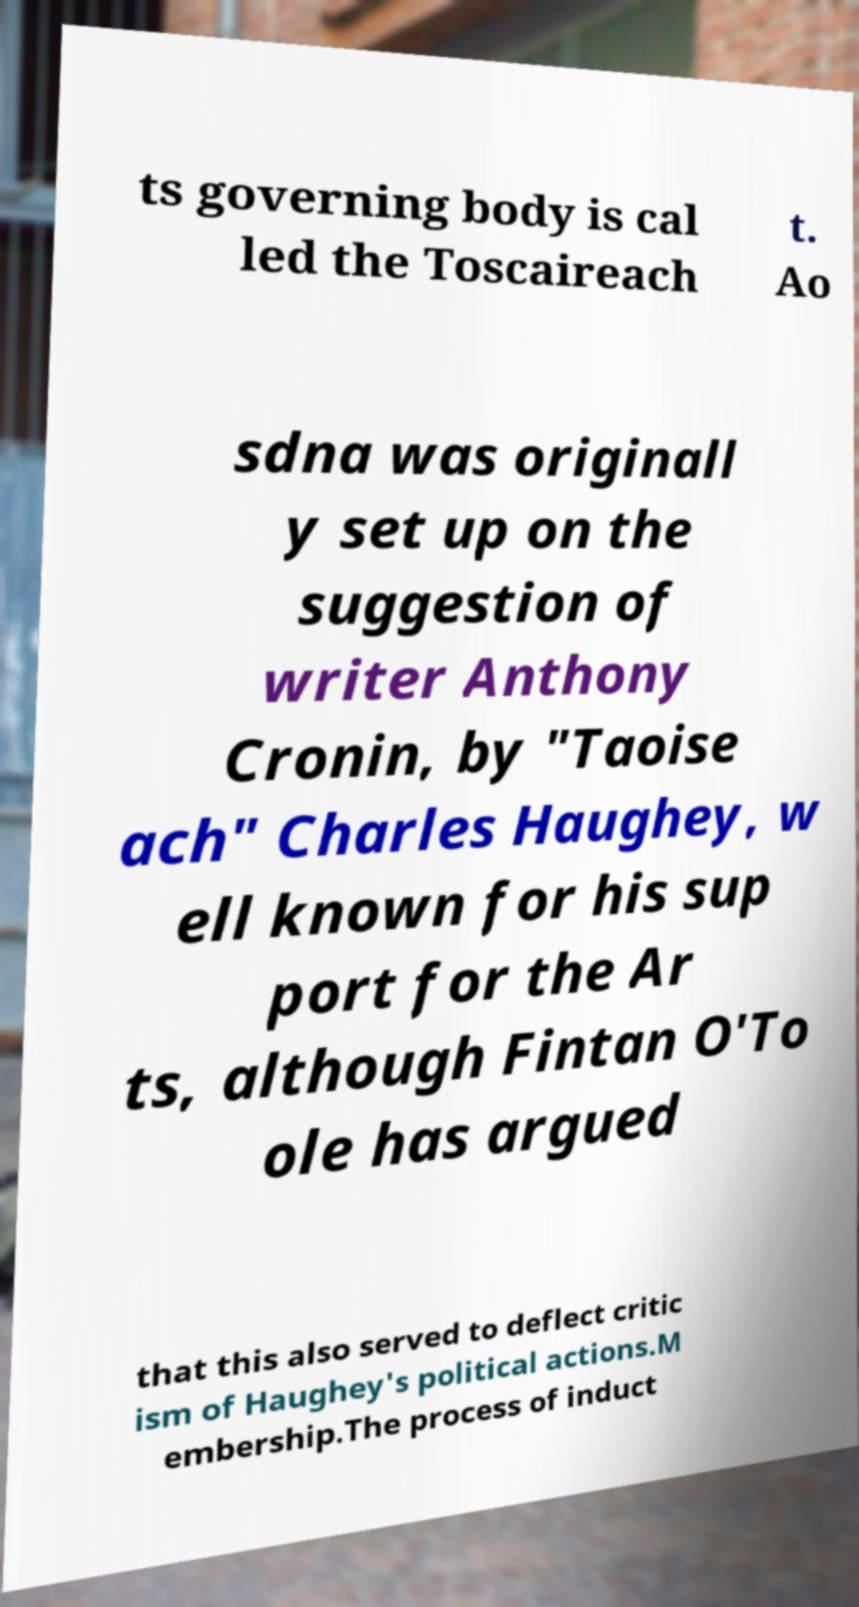What messages or text are displayed in this image? I need them in a readable, typed format. ts governing body is cal led the Toscaireach t. Ao sdna was originall y set up on the suggestion of writer Anthony Cronin, by "Taoise ach" Charles Haughey, w ell known for his sup port for the Ar ts, although Fintan O'To ole has argued that this also served to deflect critic ism of Haughey's political actions.M embership.The process of induct 